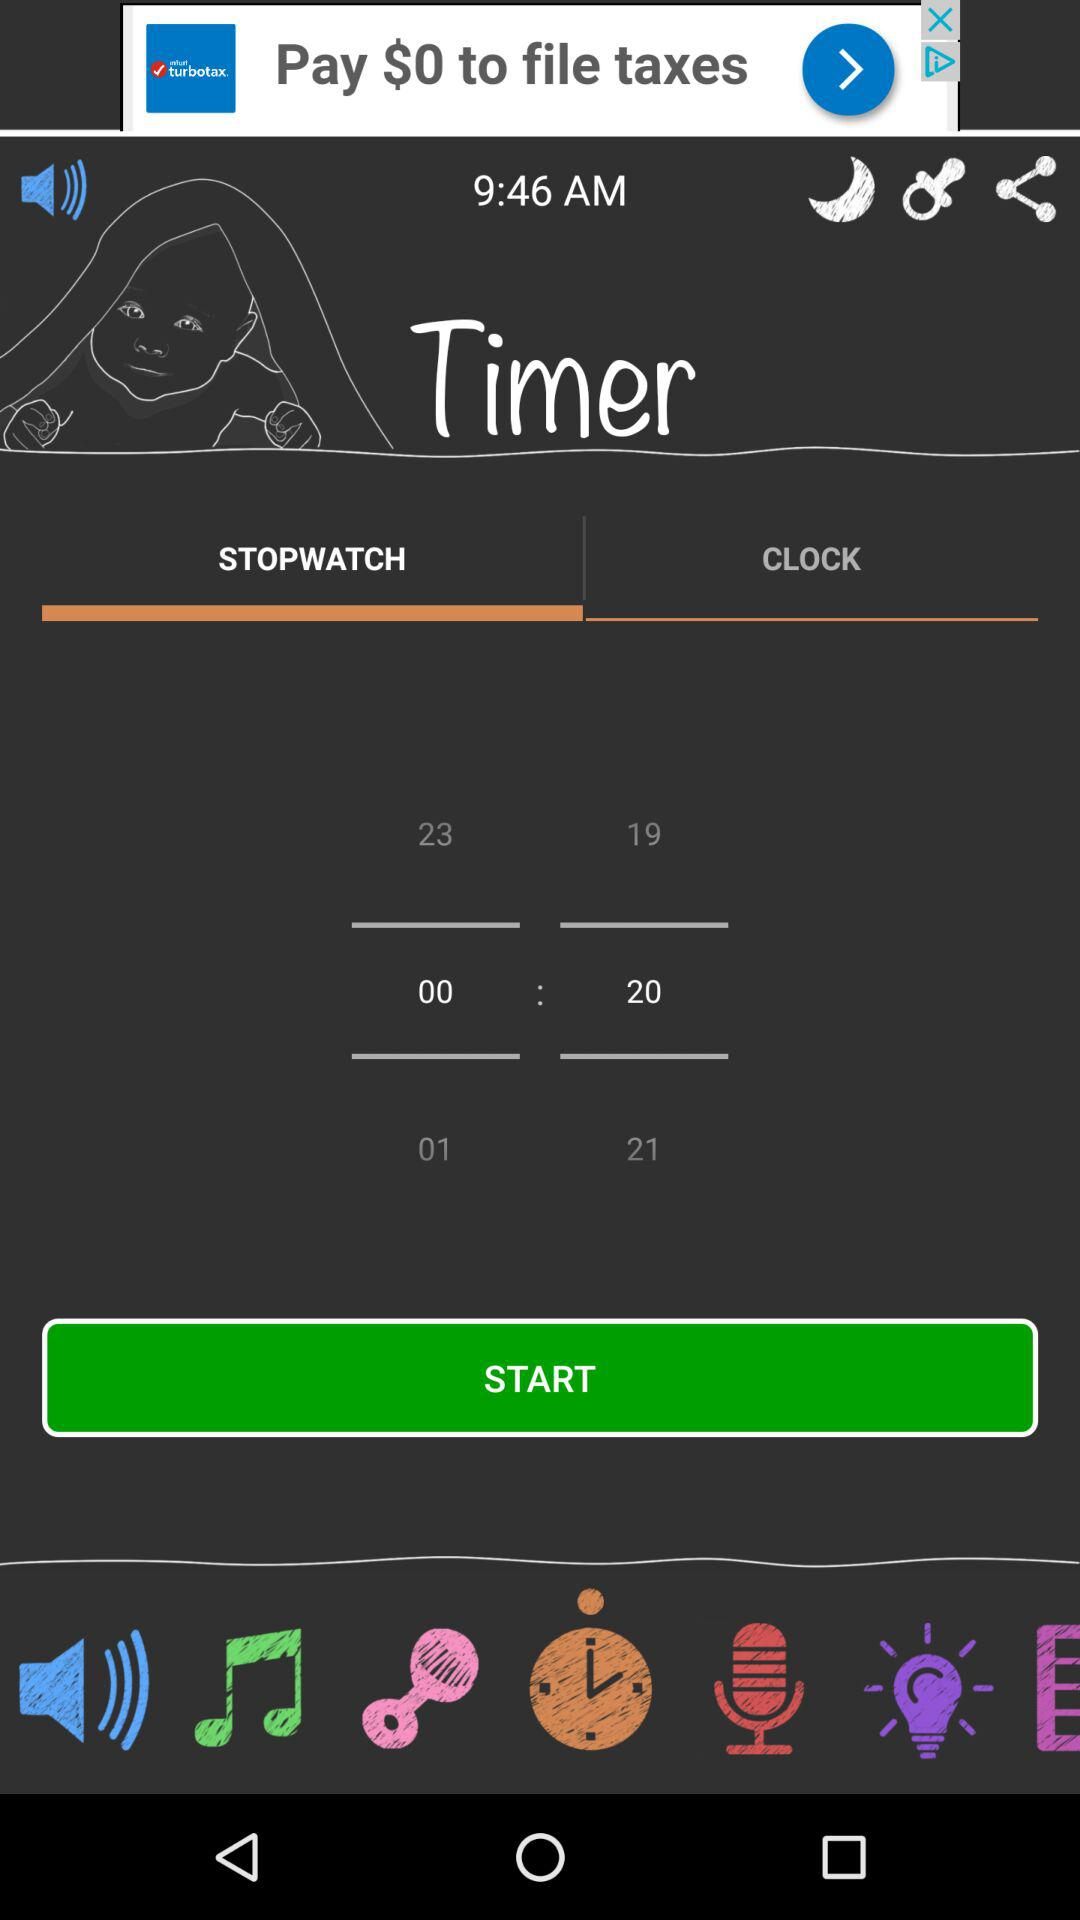What is the time? The time is 9:46 AM. 